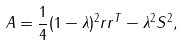<formula> <loc_0><loc_0><loc_500><loc_500>A = \frac { 1 } { 4 } ( 1 - \lambda ) ^ { 2 } r r ^ { T } - \lambda ^ { 2 } S ^ { 2 } ,</formula> 